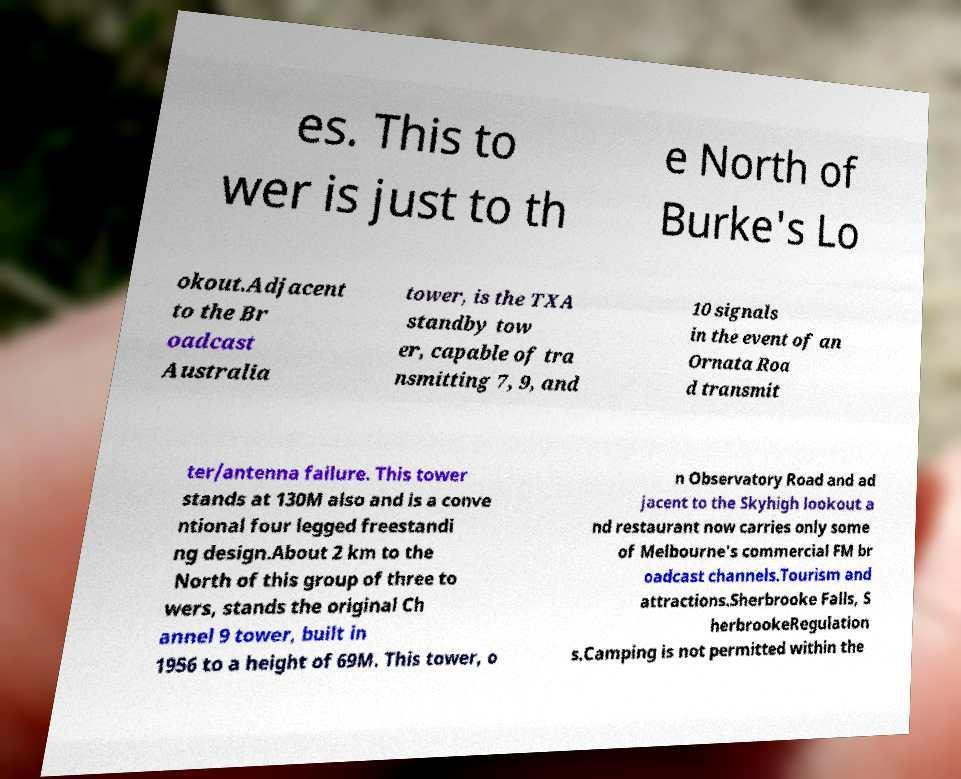Could you extract and type out the text from this image? es. This to wer is just to th e North of Burke's Lo okout.Adjacent to the Br oadcast Australia tower, is the TXA standby tow er, capable of tra nsmitting 7, 9, and 10 signals in the event of an Ornata Roa d transmit ter/antenna failure. This tower stands at 130M also and is a conve ntional four legged freestandi ng design.About 2 km to the North of this group of three to wers, stands the original Ch annel 9 tower, built in 1956 to a height of 69M. This tower, o n Observatory Road and ad jacent to the Skyhigh lookout a nd restaurant now carries only some of Melbourne's commercial FM br oadcast channels.Tourism and attractions.Sherbrooke Falls, S herbrookeRegulation s.Camping is not permitted within the 